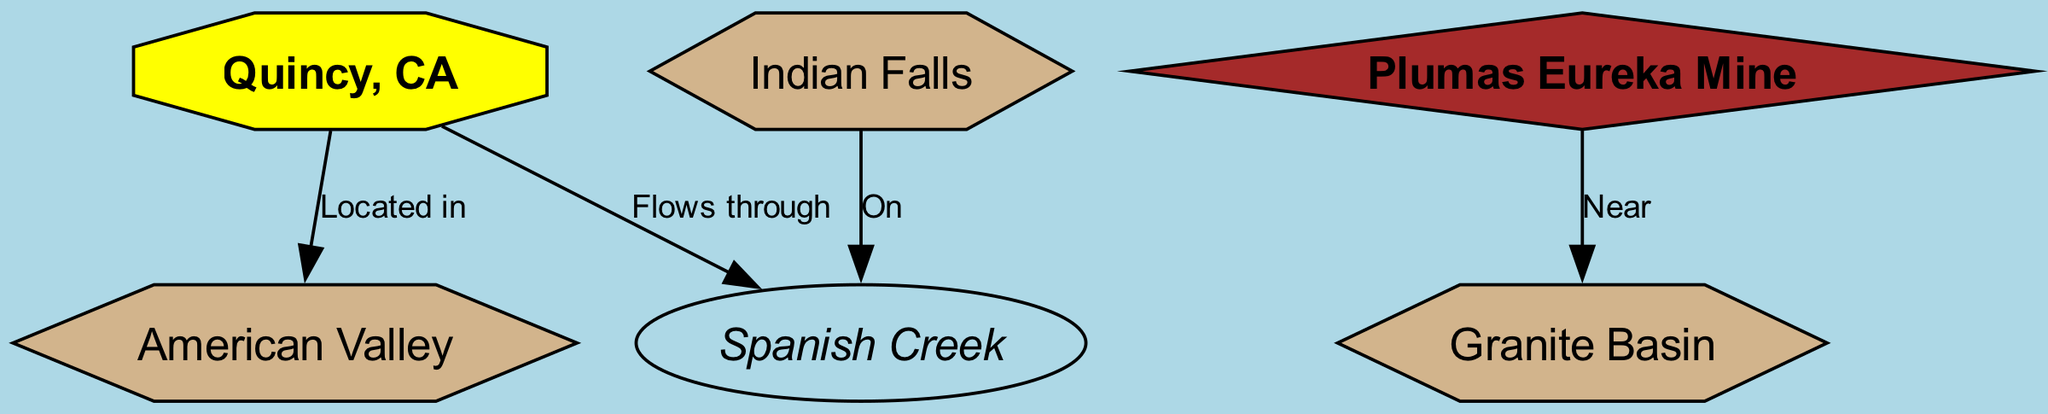What is the type of the node representing Quincy? The node labeled "Quincy, CA" is categorized as a 'town' in the diagram.
Answer: town How many geological formations are present in the diagram? The diagram features three geological formations: American Valley, Granite Basin, and Indian Falls. Hence, the total number is three.
Answer: 3 What feature does Spanish Creek have a direct relationship with? The diagram indicates that Spanish Creek "Flows through" Quincy and is also "On" Indian Falls, establishing its relationship with both.
Answer: Quincy, Indian Falls Which historical mining site is near Granite Basin? The diagram specifies that Plumas Eureka Mine is located "Near" Granite Basin, establishing the relationship for the historical mining site.
Answer: Plumas Eureka Mine Where is American Valley located in relation to Quincy? The diagram shows that American Valley is "Located in" Quincy, indicating a geographic relationship.
Answer: Located in What color represents the historical mining site in the diagram? The diagram labels the historical mining site (Plumas Eureka Mine) with a brown fill color, distinguishing it from other features.
Answer: brown What is the shape of the node for geological formations? The diagram depicts geological formations as polygons, specifically indicated as having six sides.
Answer: polygon How many edges connect the town of Quincy to other features? The diagram outlines two direct edges connecting Quincy to Spanish Creek and American Valley, establishing its relationships.
Answer: 2 What water feature is located on Indian Falls? The diagram states that Spanish Creek is "On" Indian Falls, indicating its positioning in relation to the water feature.
Answer: Spanish Creek 